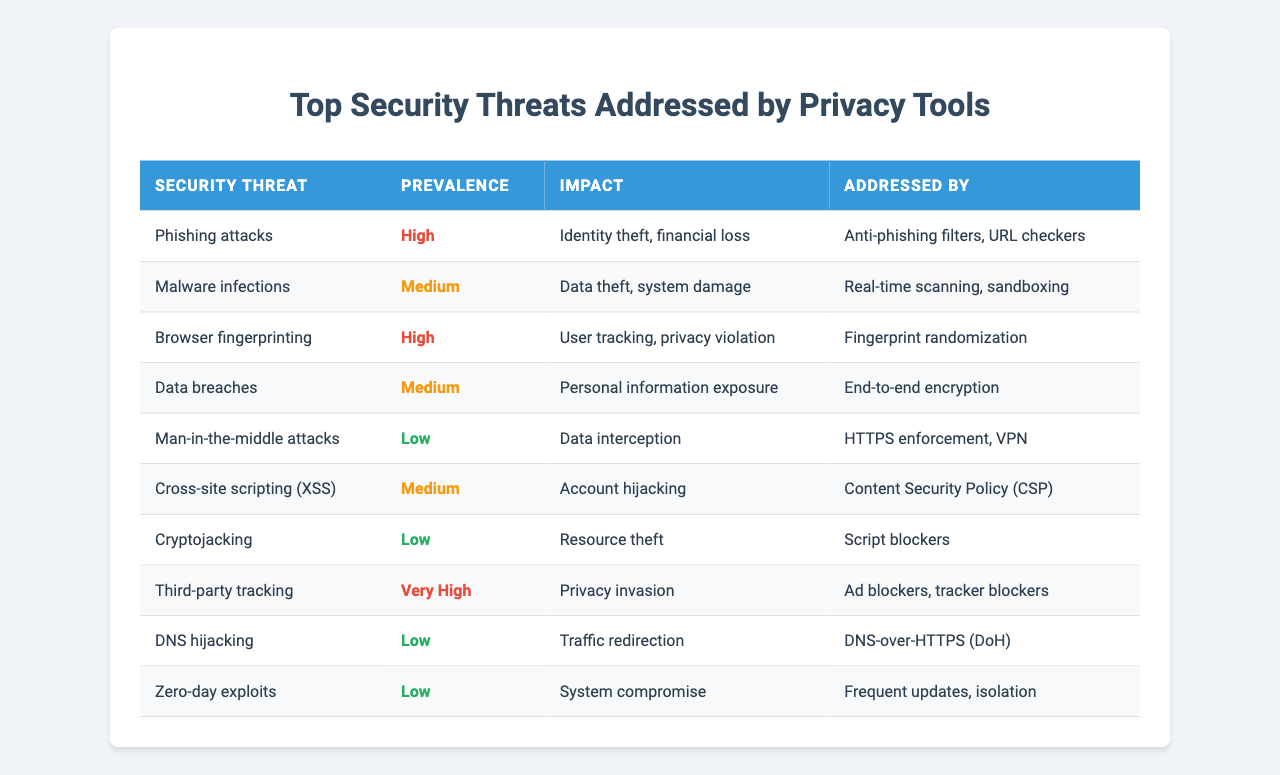What security threat has the highest prevalence? The highest prevalence in the table is classified as "Very High," which corresponds to "Third-party tracking."
Answer: Third-party tracking How many security threats are addressed by Anti-phishing filters? The table shows that "Anti-phishing filters" address one specific threat: "Phishing attacks."
Answer: One Is malware infections a security threat with high prevalence? The prevalence of "Malware infections" is listed as "Medium," therefore it does not fall into the "High" category.
Answer: No Which security threat is associated with the greatest impact according to the table? The table indicates that "Phishing attacks" have the most significant impact, which includes "Identity theft, financial loss."
Answer: Phishing attacks List the security threats that have a "Low" prevalence. The table lists "Man-in-the-middle attacks," "Cryptojacking," "DNS hijacking," and "Zero-day exploits" as threats with low prevalence.
Answer: Man-in-the-middle attacks, Cryptojacking, DNS hijacking, Zero-day exploits How many security threats have "Medium" prevalence? There are 3 threats listed with a "Medium" prevalence: "Malware infections," "Data breaches," and "Cross-site scripting (XSS)."
Answer: Three Which addressing methods are used to mitigate the threat of browser fingerprinting? The threat of browser fingerprinting is addressed by "Fingerprint randomization."
Answer: Fingerprint randomization Are data breaches considered a "High" prevalence threat? The table categorizes "Data breaches" as having "Medium" prevalence, thus it is not classified as "High."
Answer: No What is the impact of cryptojacking? The table indicates that the impact of "Cryptojacking" is resource theft.
Answer: Resource theft Determine the average impact score of threats addressed by ad blockers. The threats addressed by ad blockers are "Third-party tracking," which has the impact of "Privacy invasion," measured as a singular qualitative impact rather than a numeric score. Therefore, average cannot be determined.
Answer: Not applicable 